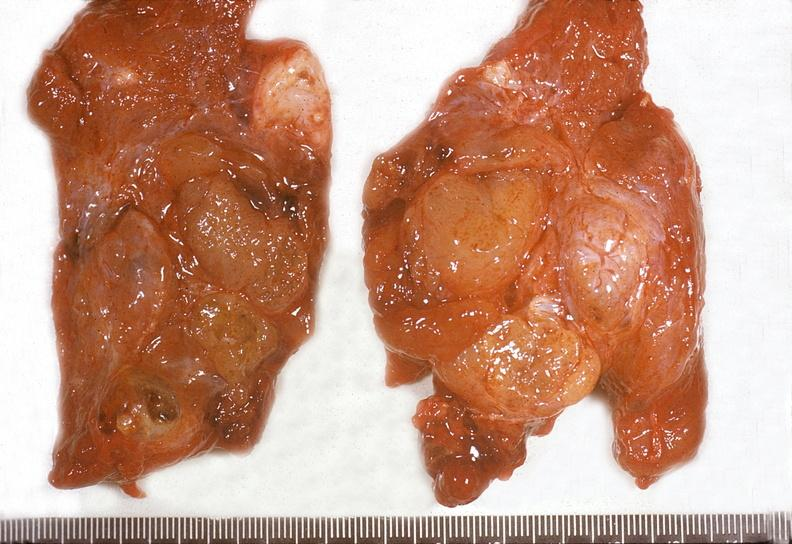s lesion of myocytolysis present?
Answer the question using a single word or phrase. No 